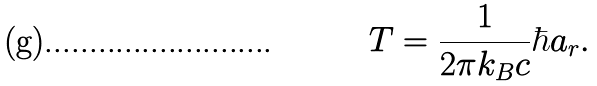<formula> <loc_0><loc_0><loc_500><loc_500>T = \frac { 1 } { 2 \pi k _ { B } c } \hbar { a } _ { r } .</formula> 